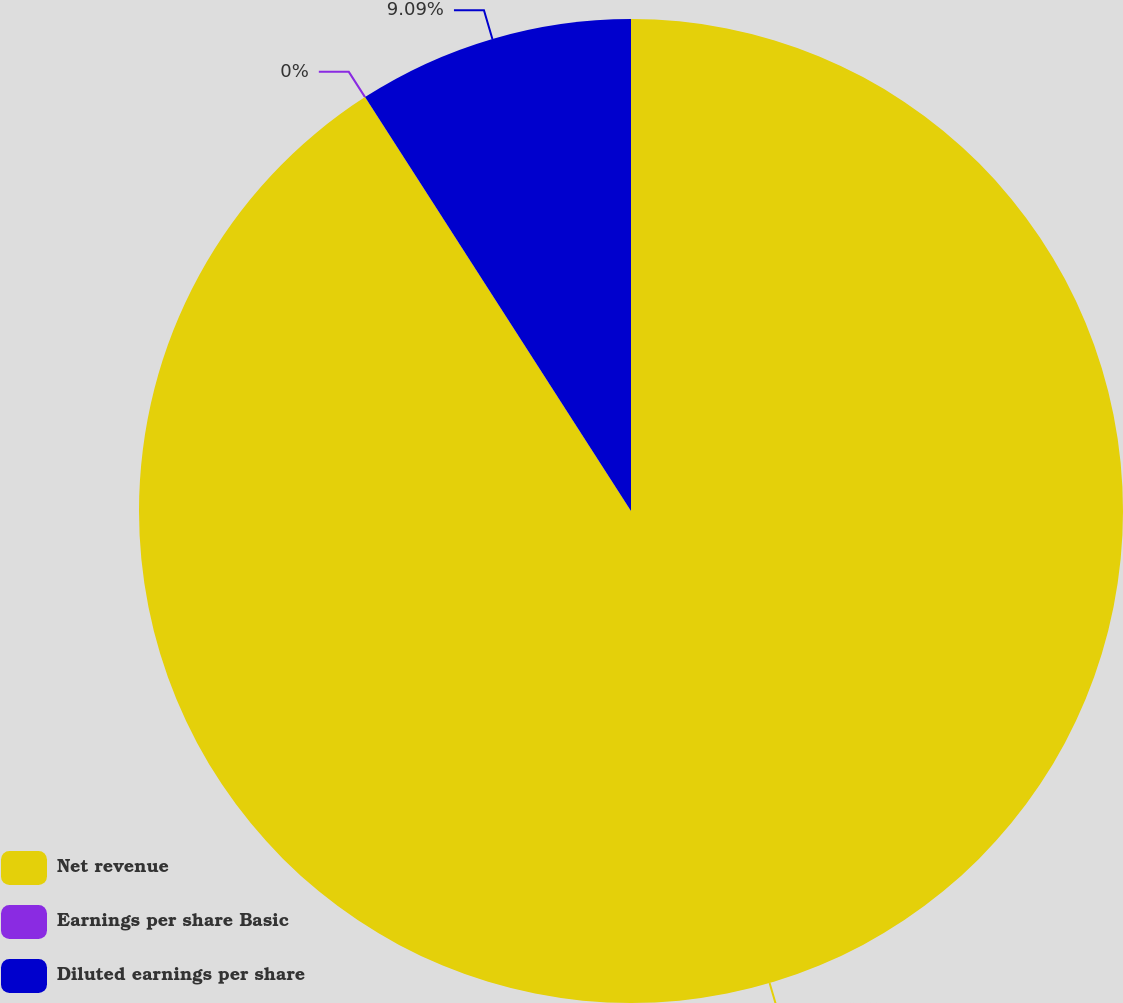<chart> <loc_0><loc_0><loc_500><loc_500><pie_chart><fcel>Net revenue<fcel>Earnings per share Basic<fcel>Diluted earnings per share<nl><fcel>90.91%<fcel>0.0%<fcel>9.09%<nl></chart> 